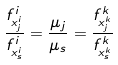<formula> <loc_0><loc_0><loc_500><loc_500>\frac { f _ { x _ { j } ^ { i } } ^ { i } } { f _ { x _ { s } ^ { i } } ^ { i } } = \frac { \mu _ { j } } { \mu _ { s } } = \frac { f _ { x _ { j } ^ { k } } ^ { k } } { f _ { x _ { s } ^ { k } } ^ { k } }</formula> 